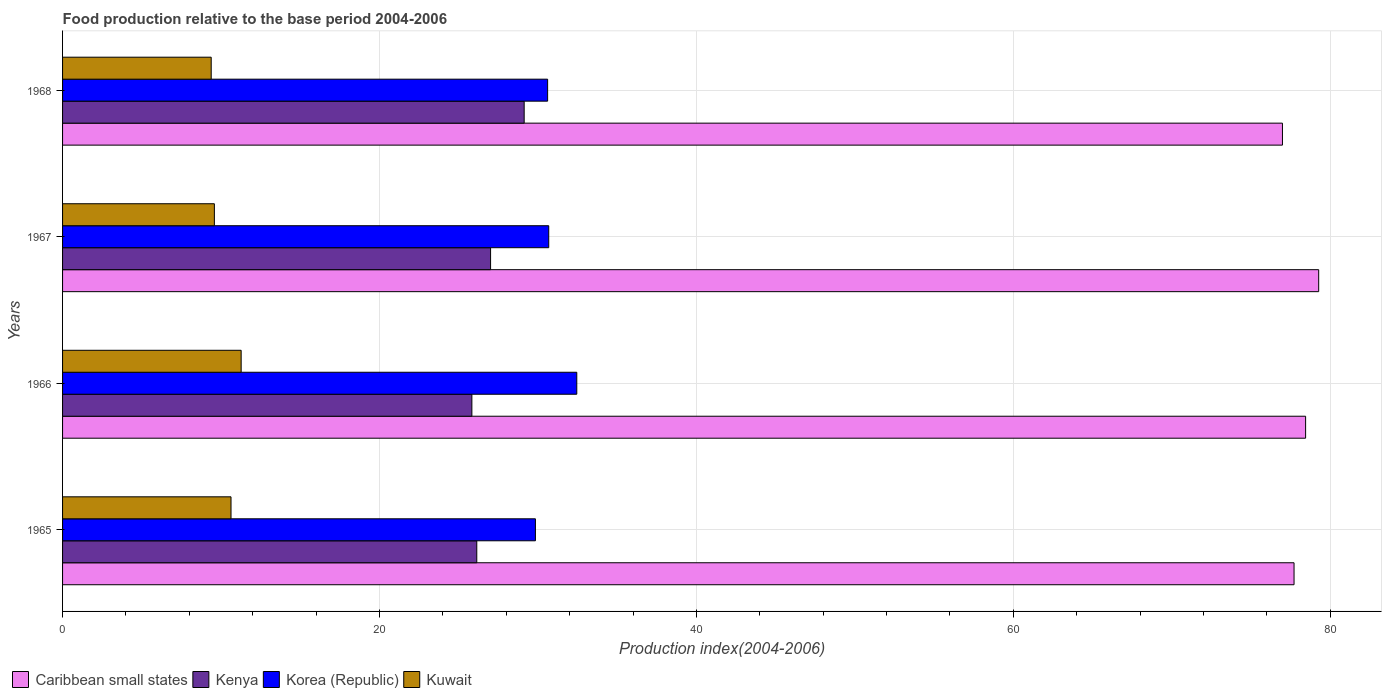How many different coloured bars are there?
Give a very brief answer. 4. Are the number of bars per tick equal to the number of legend labels?
Keep it short and to the point. Yes. Are the number of bars on each tick of the Y-axis equal?
Offer a very short reply. Yes. How many bars are there on the 1st tick from the top?
Offer a terse response. 4. How many bars are there on the 1st tick from the bottom?
Make the answer very short. 4. What is the label of the 2nd group of bars from the top?
Give a very brief answer. 1967. What is the food production index in Korea (Republic) in 1966?
Provide a short and direct response. 32.45. Across all years, what is the maximum food production index in Korea (Republic)?
Keep it short and to the point. 32.45. Across all years, what is the minimum food production index in Kuwait?
Your answer should be compact. 9.38. In which year was the food production index in Korea (Republic) maximum?
Your response must be concise. 1966. In which year was the food production index in Korea (Republic) minimum?
Ensure brevity in your answer.  1965. What is the total food production index in Kenya in the graph?
Give a very brief answer. 108.11. What is the difference between the food production index in Caribbean small states in 1967 and that in 1968?
Your answer should be compact. 2.29. What is the difference between the food production index in Caribbean small states in 1967 and the food production index in Kuwait in 1968?
Provide a succinct answer. 69.89. What is the average food production index in Kenya per year?
Keep it short and to the point. 27.03. In the year 1967, what is the difference between the food production index in Kuwait and food production index in Korea (Republic)?
Your response must be concise. -21.1. In how many years, is the food production index in Caribbean small states greater than 24 ?
Keep it short and to the point. 4. What is the ratio of the food production index in Caribbean small states in 1965 to that in 1968?
Keep it short and to the point. 1.01. Is the difference between the food production index in Kuwait in 1965 and 1966 greater than the difference between the food production index in Korea (Republic) in 1965 and 1966?
Give a very brief answer. Yes. What is the difference between the highest and the second highest food production index in Kenya?
Offer a terse response. 2.12. What is the difference between the highest and the lowest food production index in Kenya?
Offer a very short reply. 3.3. Is it the case that in every year, the sum of the food production index in Korea (Republic) and food production index in Kenya is greater than the sum of food production index in Caribbean small states and food production index in Kuwait?
Provide a succinct answer. No. What does the 3rd bar from the top in 1965 represents?
Your response must be concise. Kenya. Is it the case that in every year, the sum of the food production index in Caribbean small states and food production index in Kuwait is greater than the food production index in Korea (Republic)?
Your response must be concise. Yes. Are all the bars in the graph horizontal?
Offer a very short reply. Yes. How many years are there in the graph?
Make the answer very short. 4. Are the values on the major ticks of X-axis written in scientific E-notation?
Your answer should be very brief. No. Does the graph contain any zero values?
Provide a short and direct response. No. Where does the legend appear in the graph?
Keep it short and to the point. Bottom left. How many legend labels are there?
Offer a terse response. 4. How are the legend labels stacked?
Keep it short and to the point. Horizontal. What is the title of the graph?
Provide a short and direct response. Food production relative to the base period 2004-2006. Does "Bolivia" appear as one of the legend labels in the graph?
Offer a very short reply. No. What is the label or title of the X-axis?
Provide a succinct answer. Production index(2004-2006). What is the Production index(2004-2006) in Caribbean small states in 1965?
Your answer should be very brief. 77.71. What is the Production index(2004-2006) in Kenya in 1965?
Give a very brief answer. 26.14. What is the Production index(2004-2006) in Korea (Republic) in 1965?
Offer a very short reply. 29.84. What is the Production index(2004-2006) in Kuwait in 1965?
Offer a very short reply. 10.63. What is the Production index(2004-2006) in Caribbean small states in 1966?
Provide a short and direct response. 78.44. What is the Production index(2004-2006) of Kenya in 1966?
Offer a very short reply. 25.83. What is the Production index(2004-2006) in Korea (Republic) in 1966?
Make the answer very short. 32.45. What is the Production index(2004-2006) in Kuwait in 1966?
Provide a succinct answer. 11.27. What is the Production index(2004-2006) of Caribbean small states in 1967?
Provide a short and direct response. 79.27. What is the Production index(2004-2006) of Kenya in 1967?
Your answer should be very brief. 27.01. What is the Production index(2004-2006) in Korea (Republic) in 1967?
Ensure brevity in your answer.  30.68. What is the Production index(2004-2006) of Kuwait in 1967?
Offer a terse response. 9.58. What is the Production index(2004-2006) of Caribbean small states in 1968?
Give a very brief answer. 76.98. What is the Production index(2004-2006) in Kenya in 1968?
Your response must be concise. 29.13. What is the Production index(2004-2006) in Korea (Republic) in 1968?
Offer a terse response. 30.61. What is the Production index(2004-2006) of Kuwait in 1968?
Keep it short and to the point. 9.38. Across all years, what is the maximum Production index(2004-2006) of Caribbean small states?
Provide a succinct answer. 79.27. Across all years, what is the maximum Production index(2004-2006) of Kenya?
Keep it short and to the point. 29.13. Across all years, what is the maximum Production index(2004-2006) of Korea (Republic)?
Your answer should be compact. 32.45. Across all years, what is the maximum Production index(2004-2006) of Kuwait?
Provide a succinct answer. 11.27. Across all years, what is the minimum Production index(2004-2006) of Caribbean small states?
Give a very brief answer. 76.98. Across all years, what is the minimum Production index(2004-2006) of Kenya?
Your response must be concise. 25.83. Across all years, what is the minimum Production index(2004-2006) of Korea (Republic)?
Keep it short and to the point. 29.84. Across all years, what is the minimum Production index(2004-2006) in Kuwait?
Your response must be concise. 9.38. What is the total Production index(2004-2006) of Caribbean small states in the graph?
Give a very brief answer. 312.41. What is the total Production index(2004-2006) in Kenya in the graph?
Ensure brevity in your answer.  108.11. What is the total Production index(2004-2006) in Korea (Republic) in the graph?
Keep it short and to the point. 123.58. What is the total Production index(2004-2006) in Kuwait in the graph?
Offer a very short reply. 40.86. What is the difference between the Production index(2004-2006) in Caribbean small states in 1965 and that in 1966?
Offer a very short reply. -0.73. What is the difference between the Production index(2004-2006) in Kenya in 1965 and that in 1966?
Offer a very short reply. 0.31. What is the difference between the Production index(2004-2006) in Korea (Republic) in 1965 and that in 1966?
Provide a succinct answer. -2.61. What is the difference between the Production index(2004-2006) of Kuwait in 1965 and that in 1966?
Your answer should be compact. -0.64. What is the difference between the Production index(2004-2006) of Caribbean small states in 1965 and that in 1967?
Your response must be concise. -1.56. What is the difference between the Production index(2004-2006) of Kenya in 1965 and that in 1967?
Keep it short and to the point. -0.87. What is the difference between the Production index(2004-2006) of Korea (Republic) in 1965 and that in 1967?
Your answer should be compact. -0.84. What is the difference between the Production index(2004-2006) in Kuwait in 1965 and that in 1967?
Ensure brevity in your answer.  1.05. What is the difference between the Production index(2004-2006) of Caribbean small states in 1965 and that in 1968?
Provide a succinct answer. 0.73. What is the difference between the Production index(2004-2006) of Kenya in 1965 and that in 1968?
Your answer should be compact. -2.99. What is the difference between the Production index(2004-2006) of Korea (Republic) in 1965 and that in 1968?
Your answer should be compact. -0.77. What is the difference between the Production index(2004-2006) of Caribbean small states in 1966 and that in 1967?
Ensure brevity in your answer.  -0.82. What is the difference between the Production index(2004-2006) in Kenya in 1966 and that in 1967?
Your response must be concise. -1.18. What is the difference between the Production index(2004-2006) of Korea (Republic) in 1966 and that in 1967?
Give a very brief answer. 1.77. What is the difference between the Production index(2004-2006) in Kuwait in 1966 and that in 1967?
Keep it short and to the point. 1.69. What is the difference between the Production index(2004-2006) of Caribbean small states in 1966 and that in 1968?
Your answer should be very brief. 1.46. What is the difference between the Production index(2004-2006) of Korea (Republic) in 1966 and that in 1968?
Offer a terse response. 1.84. What is the difference between the Production index(2004-2006) of Kuwait in 1966 and that in 1968?
Make the answer very short. 1.89. What is the difference between the Production index(2004-2006) in Caribbean small states in 1967 and that in 1968?
Your answer should be very brief. 2.29. What is the difference between the Production index(2004-2006) in Kenya in 1967 and that in 1968?
Ensure brevity in your answer.  -2.12. What is the difference between the Production index(2004-2006) of Korea (Republic) in 1967 and that in 1968?
Offer a terse response. 0.07. What is the difference between the Production index(2004-2006) of Caribbean small states in 1965 and the Production index(2004-2006) of Kenya in 1966?
Ensure brevity in your answer.  51.88. What is the difference between the Production index(2004-2006) of Caribbean small states in 1965 and the Production index(2004-2006) of Korea (Republic) in 1966?
Provide a short and direct response. 45.26. What is the difference between the Production index(2004-2006) of Caribbean small states in 1965 and the Production index(2004-2006) of Kuwait in 1966?
Provide a succinct answer. 66.44. What is the difference between the Production index(2004-2006) in Kenya in 1965 and the Production index(2004-2006) in Korea (Republic) in 1966?
Offer a very short reply. -6.31. What is the difference between the Production index(2004-2006) of Kenya in 1965 and the Production index(2004-2006) of Kuwait in 1966?
Keep it short and to the point. 14.87. What is the difference between the Production index(2004-2006) in Korea (Republic) in 1965 and the Production index(2004-2006) in Kuwait in 1966?
Your response must be concise. 18.57. What is the difference between the Production index(2004-2006) of Caribbean small states in 1965 and the Production index(2004-2006) of Kenya in 1967?
Offer a very short reply. 50.7. What is the difference between the Production index(2004-2006) in Caribbean small states in 1965 and the Production index(2004-2006) in Korea (Republic) in 1967?
Your answer should be compact. 47.03. What is the difference between the Production index(2004-2006) of Caribbean small states in 1965 and the Production index(2004-2006) of Kuwait in 1967?
Your response must be concise. 68.13. What is the difference between the Production index(2004-2006) in Kenya in 1965 and the Production index(2004-2006) in Korea (Republic) in 1967?
Provide a succinct answer. -4.54. What is the difference between the Production index(2004-2006) in Kenya in 1965 and the Production index(2004-2006) in Kuwait in 1967?
Your answer should be compact. 16.56. What is the difference between the Production index(2004-2006) of Korea (Republic) in 1965 and the Production index(2004-2006) of Kuwait in 1967?
Make the answer very short. 20.26. What is the difference between the Production index(2004-2006) of Caribbean small states in 1965 and the Production index(2004-2006) of Kenya in 1968?
Make the answer very short. 48.58. What is the difference between the Production index(2004-2006) in Caribbean small states in 1965 and the Production index(2004-2006) in Korea (Republic) in 1968?
Keep it short and to the point. 47.1. What is the difference between the Production index(2004-2006) of Caribbean small states in 1965 and the Production index(2004-2006) of Kuwait in 1968?
Your answer should be compact. 68.33. What is the difference between the Production index(2004-2006) in Kenya in 1965 and the Production index(2004-2006) in Korea (Republic) in 1968?
Keep it short and to the point. -4.47. What is the difference between the Production index(2004-2006) of Kenya in 1965 and the Production index(2004-2006) of Kuwait in 1968?
Provide a succinct answer. 16.76. What is the difference between the Production index(2004-2006) in Korea (Republic) in 1965 and the Production index(2004-2006) in Kuwait in 1968?
Keep it short and to the point. 20.46. What is the difference between the Production index(2004-2006) of Caribbean small states in 1966 and the Production index(2004-2006) of Kenya in 1967?
Offer a very short reply. 51.43. What is the difference between the Production index(2004-2006) in Caribbean small states in 1966 and the Production index(2004-2006) in Korea (Republic) in 1967?
Your answer should be compact. 47.76. What is the difference between the Production index(2004-2006) of Caribbean small states in 1966 and the Production index(2004-2006) of Kuwait in 1967?
Offer a very short reply. 68.86. What is the difference between the Production index(2004-2006) in Kenya in 1966 and the Production index(2004-2006) in Korea (Republic) in 1967?
Give a very brief answer. -4.85. What is the difference between the Production index(2004-2006) in Kenya in 1966 and the Production index(2004-2006) in Kuwait in 1967?
Your answer should be compact. 16.25. What is the difference between the Production index(2004-2006) in Korea (Republic) in 1966 and the Production index(2004-2006) in Kuwait in 1967?
Provide a succinct answer. 22.87. What is the difference between the Production index(2004-2006) in Caribbean small states in 1966 and the Production index(2004-2006) in Kenya in 1968?
Offer a terse response. 49.31. What is the difference between the Production index(2004-2006) in Caribbean small states in 1966 and the Production index(2004-2006) in Korea (Republic) in 1968?
Ensure brevity in your answer.  47.83. What is the difference between the Production index(2004-2006) in Caribbean small states in 1966 and the Production index(2004-2006) in Kuwait in 1968?
Provide a succinct answer. 69.06. What is the difference between the Production index(2004-2006) of Kenya in 1966 and the Production index(2004-2006) of Korea (Republic) in 1968?
Your answer should be very brief. -4.78. What is the difference between the Production index(2004-2006) of Kenya in 1966 and the Production index(2004-2006) of Kuwait in 1968?
Make the answer very short. 16.45. What is the difference between the Production index(2004-2006) in Korea (Republic) in 1966 and the Production index(2004-2006) in Kuwait in 1968?
Give a very brief answer. 23.07. What is the difference between the Production index(2004-2006) of Caribbean small states in 1967 and the Production index(2004-2006) of Kenya in 1968?
Make the answer very short. 50.14. What is the difference between the Production index(2004-2006) in Caribbean small states in 1967 and the Production index(2004-2006) in Korea (Republic) in 1968?
Ensure brevity in your answer.  48.66. What is the difference between the Production index(2004-2006) in Caribbean small states in 1967 and the Production index(2004-2006) in Kuwait in 1968?
Offer a very short reply. 69.89. What is the difference between the Production index(2004-2006) of Kenya in 1967 and the Production index(2004-2006) of Kuwait in 1968?
Keep it short and to the point. 17.63. What is the difference between the Production index(2004-2006) of Korea (Republic) in 1967 and the Production index(2004-2006) of Kuwait in 1968?
Give a very brief answer. 21.3. What is the average Production index(2004-2006) in Caribbean small states per year?
Your answer should be compact. 78.1. What is the average Production index(2004-2006) in Kenya per year?
Ensure brevity in your answer.  27.03. What is the average Production index(2004-2006) in Korea (Republic) per year?
Provide a short and direct response. 30.89. What is the average Production index(2004-2006) in Kuwait per year?
Provide a succinct answer. 10.21. In the year 1965, what is the difference between the Production index(2004-2006) in Caribbean small states and Production index(2004-2006) in Kenya?
Offer a very short reply. 51.57. In the year 1965, what is the difference between the Production index(2004-2006) in Caribbean small states and Production index(2004-2006) in Korea (Republic)?
Your answer should be compact. 47.87. In the year 1965, what is the difference between the Production index(2004-2006) of Caribbean small states and Production index(2004-2006) of Kuwait?
Your answer should be very brief. 67.08. In the year 1965, what is the difference between the Production index(2004-2006) in Kenya and Production index(2004-2006) in Korea (Republic)?
Your answer should be compact. -3.7. In the year 1965, what is the difference between the Production index(2004-2006) in Kenya and Production index(2004-2006) in Kuwait?
Your answer should be compact. 15.51. In the year 1965, what is the difference between the Production index(2004-2006) in Korea (Republic) and Production index(2004-2006) in Kuwait?
Offer a very short reply. 19.21. In the year 1966, what is the difference between the Production index(2004-2006) of Caribbean small states and Production index(2004-2006) of Kenya?
Keep it short and to the point. 52.61. In the year 1966, what is the difference between the Production index(2004-2006) of Caribbean small states and Production index(2004-2006) of Korea (Republic)?
Provide a succinct answer. 45.99. In the year 1966, what is the difference between the Production index(2004-2006) of Caribbean small states and Production index(2004-2006) of Kuwait?
Provide a succinct answer. 67.17. In the year 1966, what is the difference between the Production index(2004-2006) of Kenya and Production index(2004-2006) of Korea (Republic)?
Provide a short and direct response. -6.62. In the year 1966, what is the difference between the Production index(2004-2006) in Kenya and Production index(2004-2006) in Kuwait?
Provide a succinct answer. 14.56. In the year 1966, what is the difference between the Production index(2004-2006) in Korea (Republic) and Production index(2004-2006) in Kuwait?
Offer a very short reply. 21.18. In the year 1967, what is the difference between the Production index(2004-2006) in Caribbean small states and Production index(2004-2006) in Kenya?
Provide a short and direct response. 52.26. In the year 1967, what is the difference between the Production index(2004-2006) in Caribbean small states and Production index(2004-2006) in Korea (Republic)?
Make the answer very short. 48.59. In the year 1967, what is the difference between the Production index(2004-2006) of Caribbean small states and Production index(2004-2006) of Kuwait?
Provide a succinct answer. 69.69. In the year 1967, what is the difference between the Production index(2004-2006) in Kenya and Production index(2004-2006) in Korea (Republic)?
Your answer should be very brief. -3.67. In the year 1967, what is the difference between the Production index(2004-2006) in Kenya and Production index(2004-2006) in Kuwait?
Your answer should be compact. 17.43. In the year 1967, what is the difference between the Production index(2004-2006) of Korea (Republic) and Production index(2004-2006) of Kuwait?
Provide a succinct answer. 21.1. In the year 1968, what is the difference between the Production index(2004-2006) of Caribbean small states and Production index(2004-2006) of Kenya?
Keep it short and to the point. 47.85. In the year 1968, what is the difference between the Production index(2004-2006) of Caribbean small states and Production index(2004-2006) of Korea (Republic)?
Make the answer very short. 46.37. In the year 1968, what is the difference between the Production index(2004-2006) of Caribbean small states and Production index(2004-2006) of Kuwait?
Your answer should be very brief. 67.6. In the year 1968, what is the difference between the Production index(2004-2006) in Kenya and Production index(2004-2006) in Korea (Republic)?
Give a very brief answer. -1.48. In the year 1968, what is the difference between the Production index(2004-2006) in Kenya and Production index(2004-2006) in Kuwait?
Offer a terse response. 19.75. In the year 1968, what is the difference between the Production index(2004-2006) in Korea (Republic) and Production index(2004-2006) in Kuwait?
Give a very brief answer. 21.23. What is the ratio of the Production index(2004-2006) in Kenya in 1965 to that in 1966?
Offer a terse response. 1.01. What is the ratio of the Production index(2004-2006) in Korea (Republic) in 1965 to that in 1966?
Ensure brevity in your answer.  0.92. What is the ratio of the Production index(2004-2006) of Kuwait in 1965 to that in 1966?
Give a very brief answer. 0.94. What is the ratio of the Production index(2004-2006) in Caribbean small states in 1965 to that in 1967?
Offer a terse response. 0.98. What is the ratio of the Production index(2004-2006) of Kenya in 1965 to that in 1967?
Offer a very short reply. 0.97. What is the ratio of the Production index(2004-2006) of Korea (Republic) in 1965 to that in 1967?
Ensure brevity in your answer.  0.97. What is the ratio of the Production index(2004-2006) in Kuwait in 1965 to that in 1967?
Make the answer very short. 1.11. What is the ratio of the Production index(2004-2006) in Caribbean small states in 1965 to that in 1968?
Provide a succinct answer. 1.01. What is the ratio of the Production index(2004-2006) in Kenya in 1965 to that in 1968?
Your response must be concise. 0.9. What is the ratio of the Production index(2004-2006) in Korea (Republic) in 1965 to that in 1968?
Your response must be concise. 0.97. What is the ratio of the Production index(2004-2006) in Kuwait in 1965 to that in 1968?
Provide a succinct answer. 1.13. What is the ratio of the Production index(2004-2006) of Kenya in 1966 to that in 1967?
Offer a very short reply. 0.96. What is the ratio of the Production index(2004-2006) of Korea (Republic) in 1966 to that in 1967?
Keep it short and to the point. 1.06. What is the ratio of the Production index(2004-2006) of Kuwait in 1966 to that in 1967?
Offer a terse response. 1.18. What is the ratio of the Production index(2004-2006) of Kenya in 1966 to that in 1968?
Your answer should be compact. 0.89. What is the ratio of the Production index(2004-2006) in Korea (Republic) in 1966 to that in 1968?
Offer a very short reply. 1.06. What is the ratio of the Production index(2004-2006) of Kuwait in 1966 to that in 1968?
Make the answer very short. 1.2. What is the ratio of the Production index(2004-2006) of Caribbean small states in 1967 to that in 1968?
Offer a very short reply. 1.03. What is the ratio of the Production index(2004-2006) in Kenya in 1967 to that in 1968?
Offer a very short reply. 0.93. What is the ratio of the Production index(2004-2006) in Kuwait in 1967 to that in 1968?
Provide a succinct answer. 1.02. What is the difference between the highest and the second highest Production index(2004-2006) of Caribbean small states?
Keep it short and to the point. 0.82. What is the difference between the highest and the second highest Production index(2004-2006) in Kenya?
Make the answer very short. 2.12. What is the difference between the highest and the second highest Production index(2004-2006) of Korea (Republic)?
Make the answer very short. 1.77. What is the difference between the highest and the second highest Production index(2004-2006) in Kuwait?
Your response must be concise. 0.64. What is the difference between the highest and the lowest Production index(2004-2006) of Caribbean small states?
Provide a short and direct response. 2.29. What is the difference between the highest and the lowest Production index(2004-2006) in Kenya?
Your answer should be compact. 3.3. What is the difference between the highest and the lowest Production index(2004-2006) in Korea (Republic)?
Make the answer very short. 2.61. What is the difference between the highest and the lowest Production index(2004-2006) of Kuwait?
Make the answer very short. 1.89. 